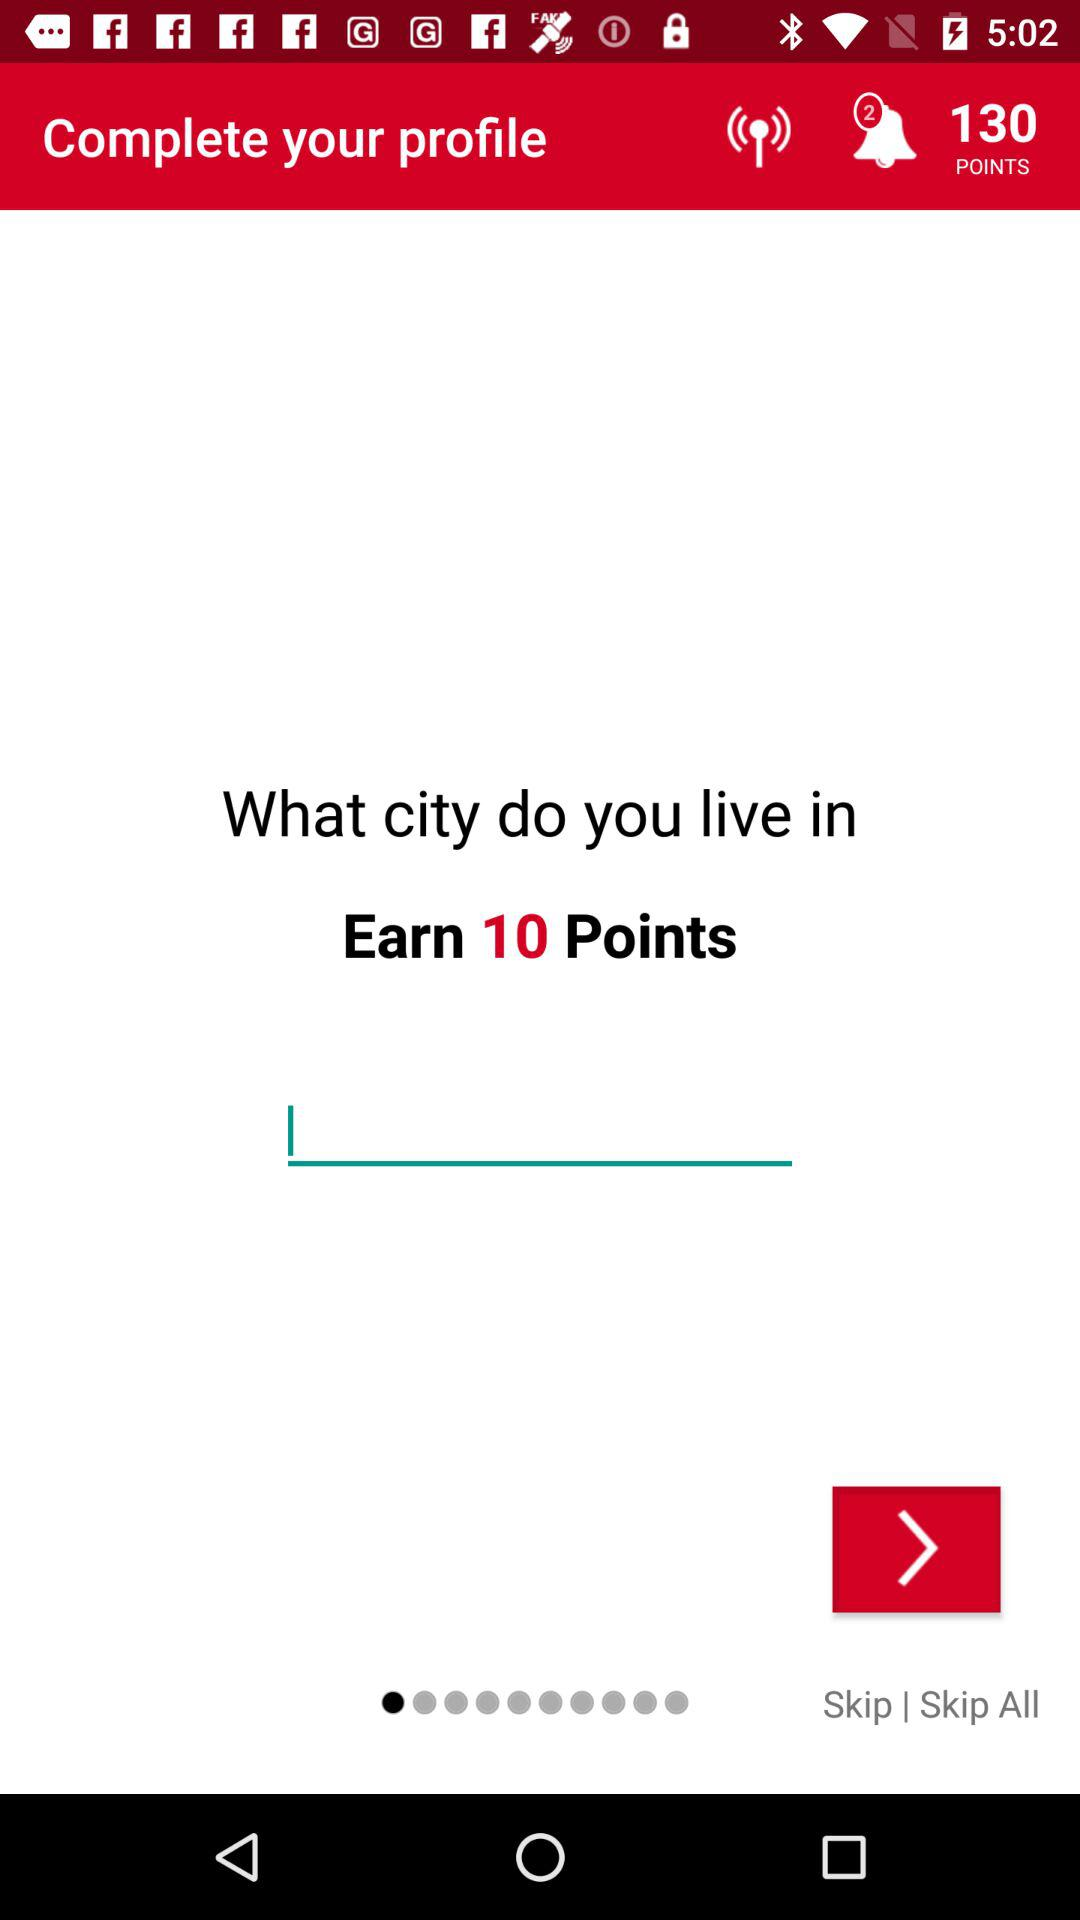How many unread notifications are there? There are 2 unread notifications. 